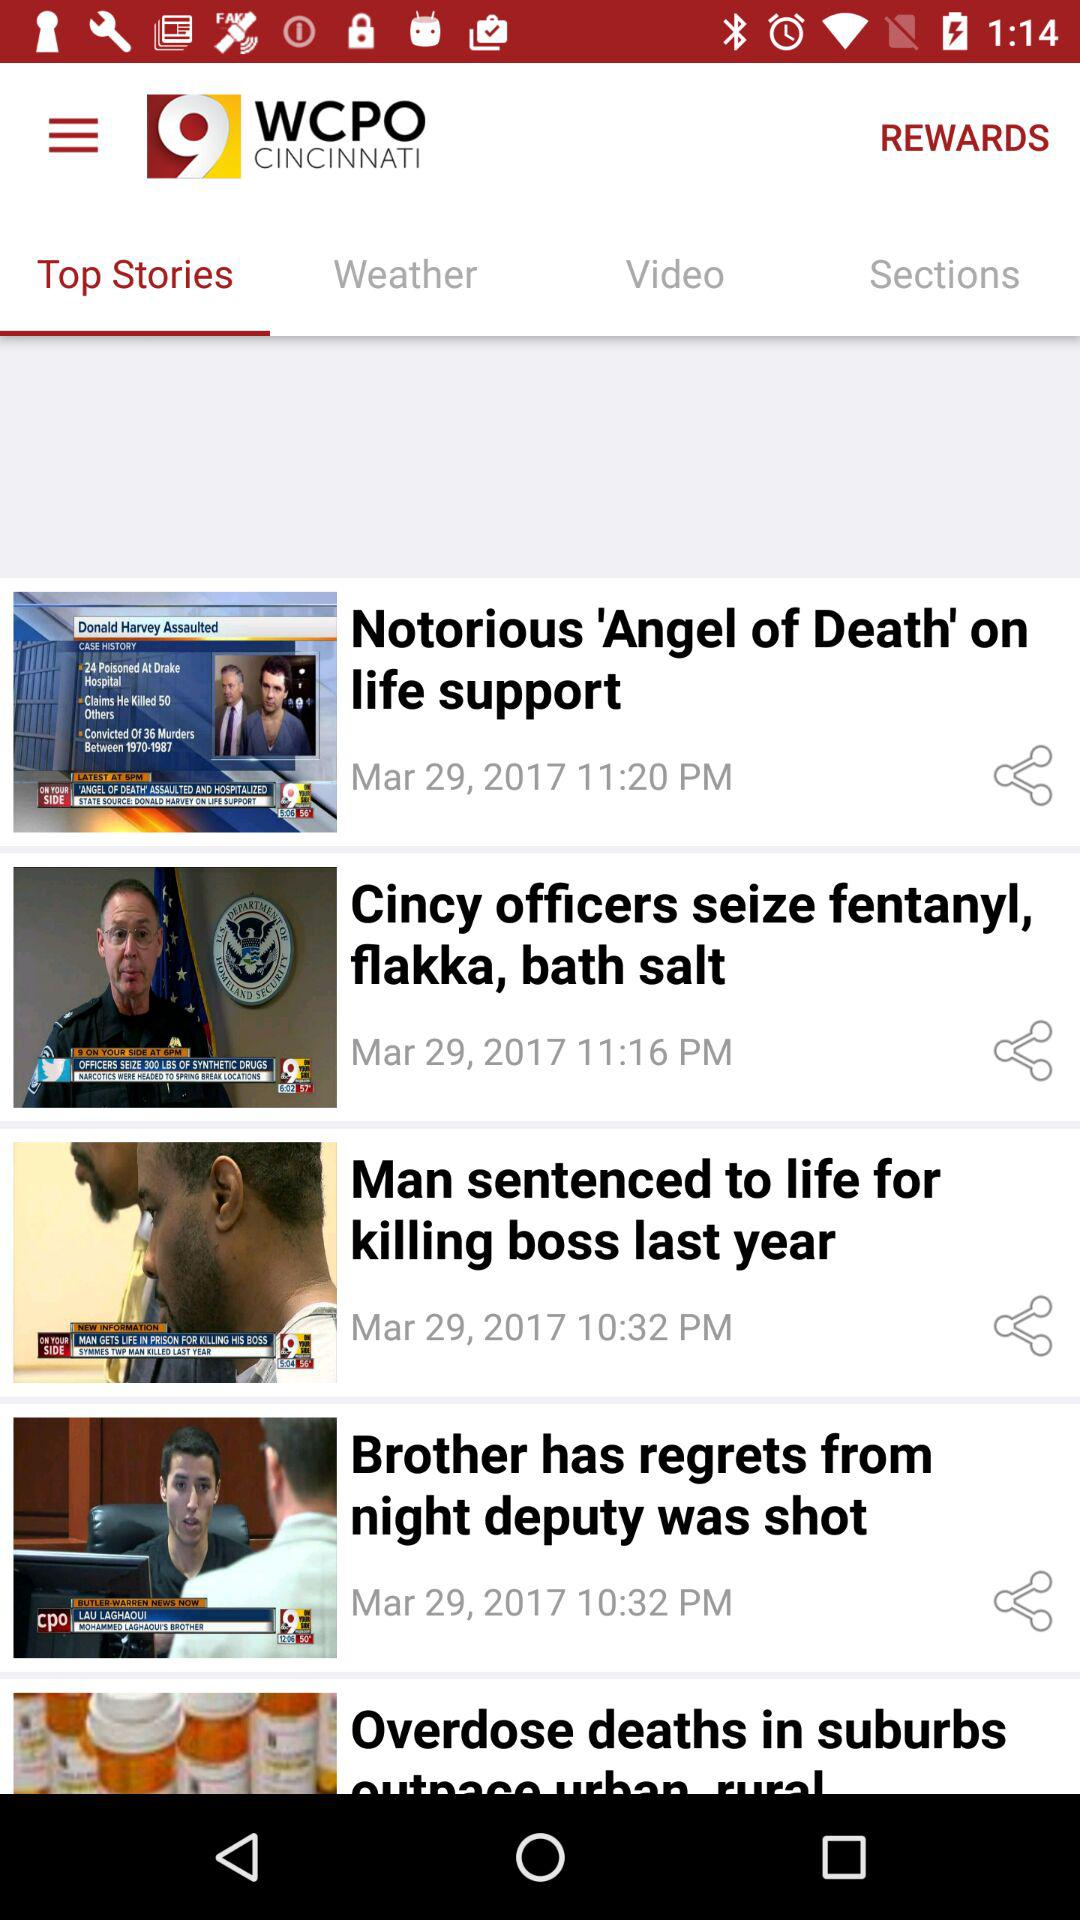What is the name of the application? The name of the application is "WCPO 9 CINCINNATI". 